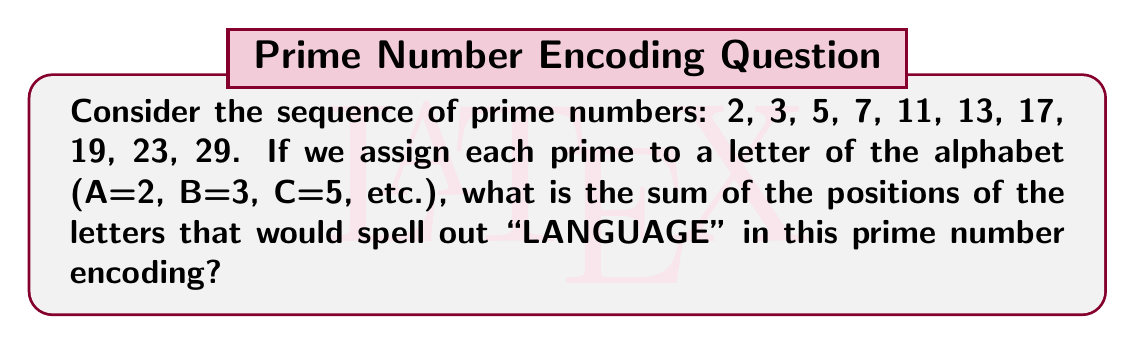Provide a solution to this math problem. Let's approach this step-by-step:

1) First, we need to assign each prime number to a letter:
   A = 2, B = 3, C = 5, D = 7, E = 11, F = 13, G = 17, H = 19, I = 23, J = 29, ...

2) Now, let's find the position of each letter in "LANGUAGE":

   L: This would be the 12th prime number (37)
   A: This is the 1st prime number (2)
   N: This would be the 14th prime number (43)
   G: This is the 7th prime number (17)
   U: This would be the 21st prime number (73)
   A: This is the 1st prime number (2)
   G: This is the 7th prime number (17)
   E: This is the 5th prime number (11)

3) Now, we need to sum these positions:

   $$12 + 1 + 14 + 7 + 21 + 1 + 7 + 5 = 68$$

Therefore, the sum of the positions is 68.
Answer: 68 